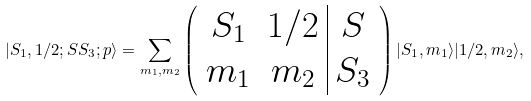Convert formula to latex. <formula><loc_0><loc_0><loc_500><loc_500>| S _ { 1 } , 1 / 2 ; S S _ { 3 } ; p \rangle = \sum _ { m _ { 1 } , m _ { 2 } } \left ( \begin{array} { c c | c } S _ { 1 } & 1 / 2 & S \\ m _ { 1 } & m _ { 2 } & S _ { 3 } \end{array} \right ) | S _ { 1 } , m _ { 1 } \rangle | 1 / 2 , m _ { 2 } \rangle ,</formula> 